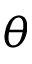Convert formula to latex. <formula><loc_0><loc_0><loc_500><loc_500>\theta</formula> 